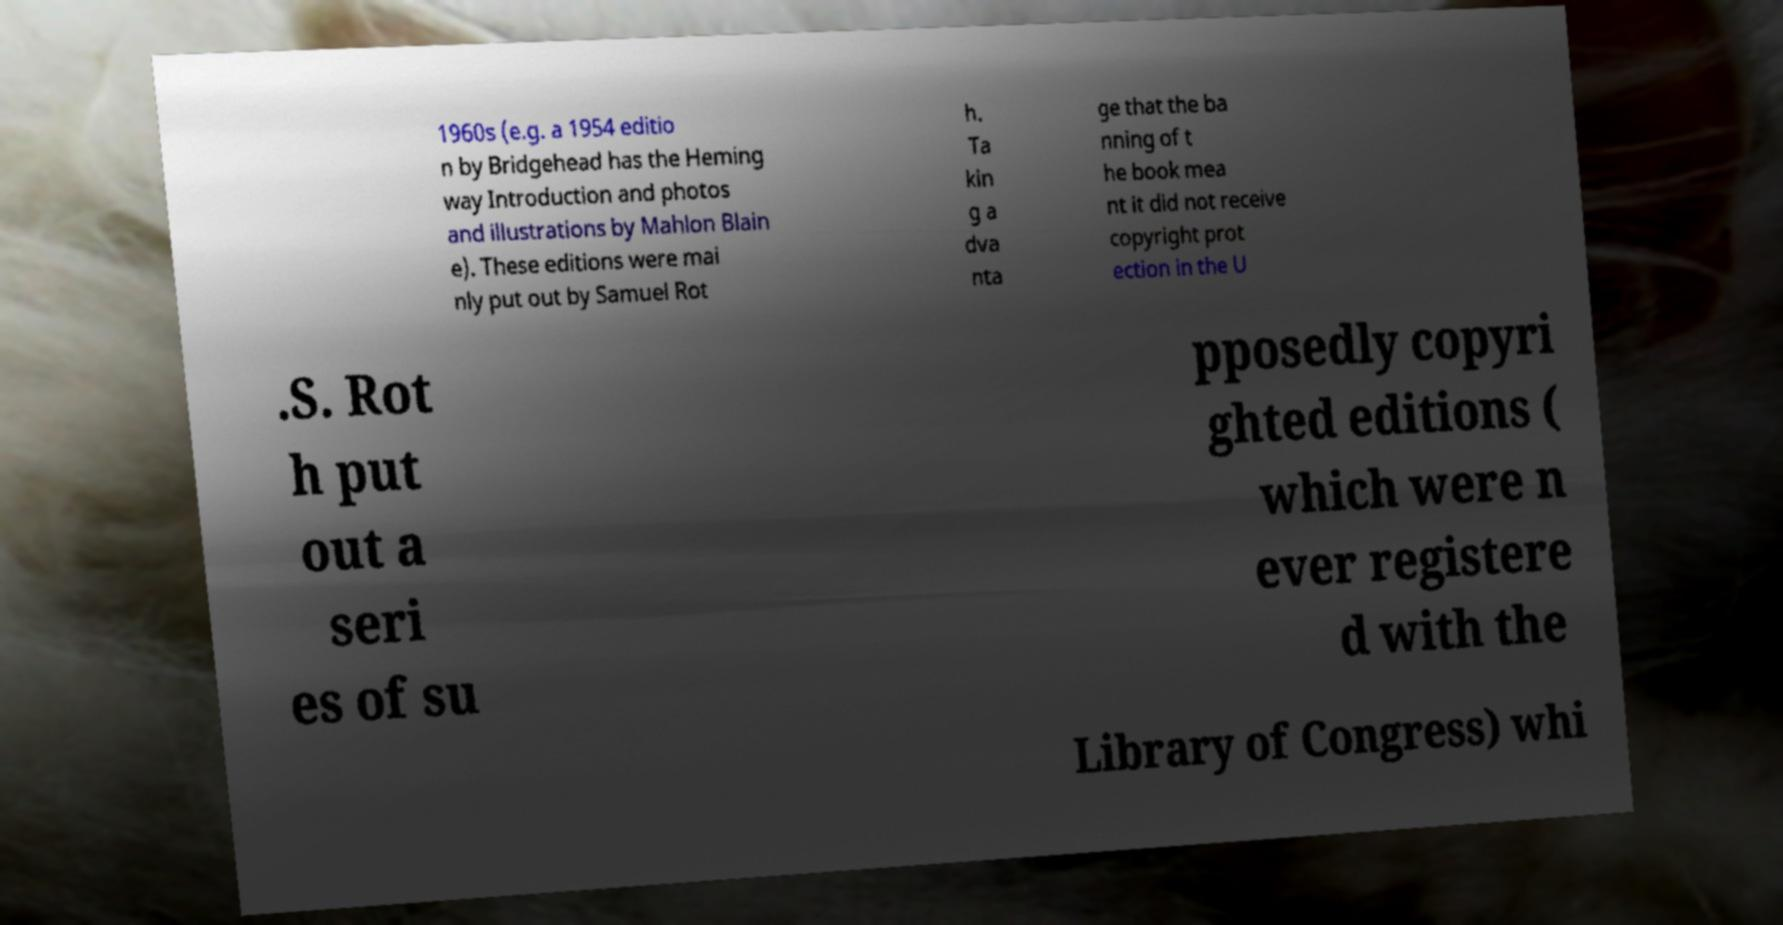Please read and relay the text visible in this image. What does it say? 1960s (e.g. a 1954 editio n by Bridgehead has the Heming way Introduction and photos and illustrations by Mahlon Blain e). These editions were mai nly put out by Samuel Rot h. Ta kin g a dva nta ge that the ba nning of t he book mea nt it did not receive copyright prot ection in the U .S. Rot h put out a seri es of su pposedly copyri ghted editions ( which were n ever registere d with the Library of Congress) whi 